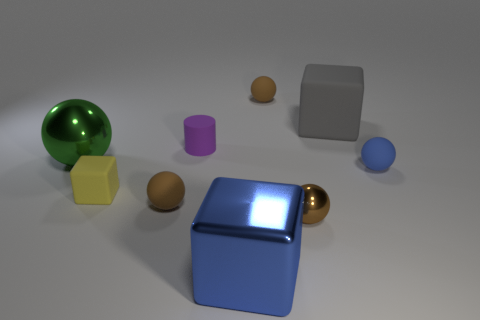Do the brown metal object and the yellow block have the same size?
Your answer should be very brief. Yes. How many things are tiny blue rubber objects in front of the cylinder or matte things that are in front of the tiny blue rubber thing?
Keep it short and to the point. 3. The block that is on the right side of the tiny brown thing that is behind the small blue rubber thing is made of what material?
Your answer should be very brief. Rubber. How many other things are the same material as the tiny purple object?
Your answer should be very brief. 5. Does the brown metal thing have the same shape as the blue matte thing?
Offer a terse response. Yes. What is the size of the metallic ball behind the yellow block?
Provide a short and direct response. Large. Do the purple cylinder and the matte ball that is right of the tiny brown shiny thing have the same size?
Your response must be concise. Yes. Are there fewer green things that are to the right of the large sphere than tiny shiny things?
Provide a short and direct response. Yes. What is the material of the big green object that is the same shape as the brown metallic thing?
Your answer should be very brief. Metal. What is the shape of the big object that is both on the right side of the yellow thing and behind the tiny brown metal thing?
Your response must be concise. Cube. 